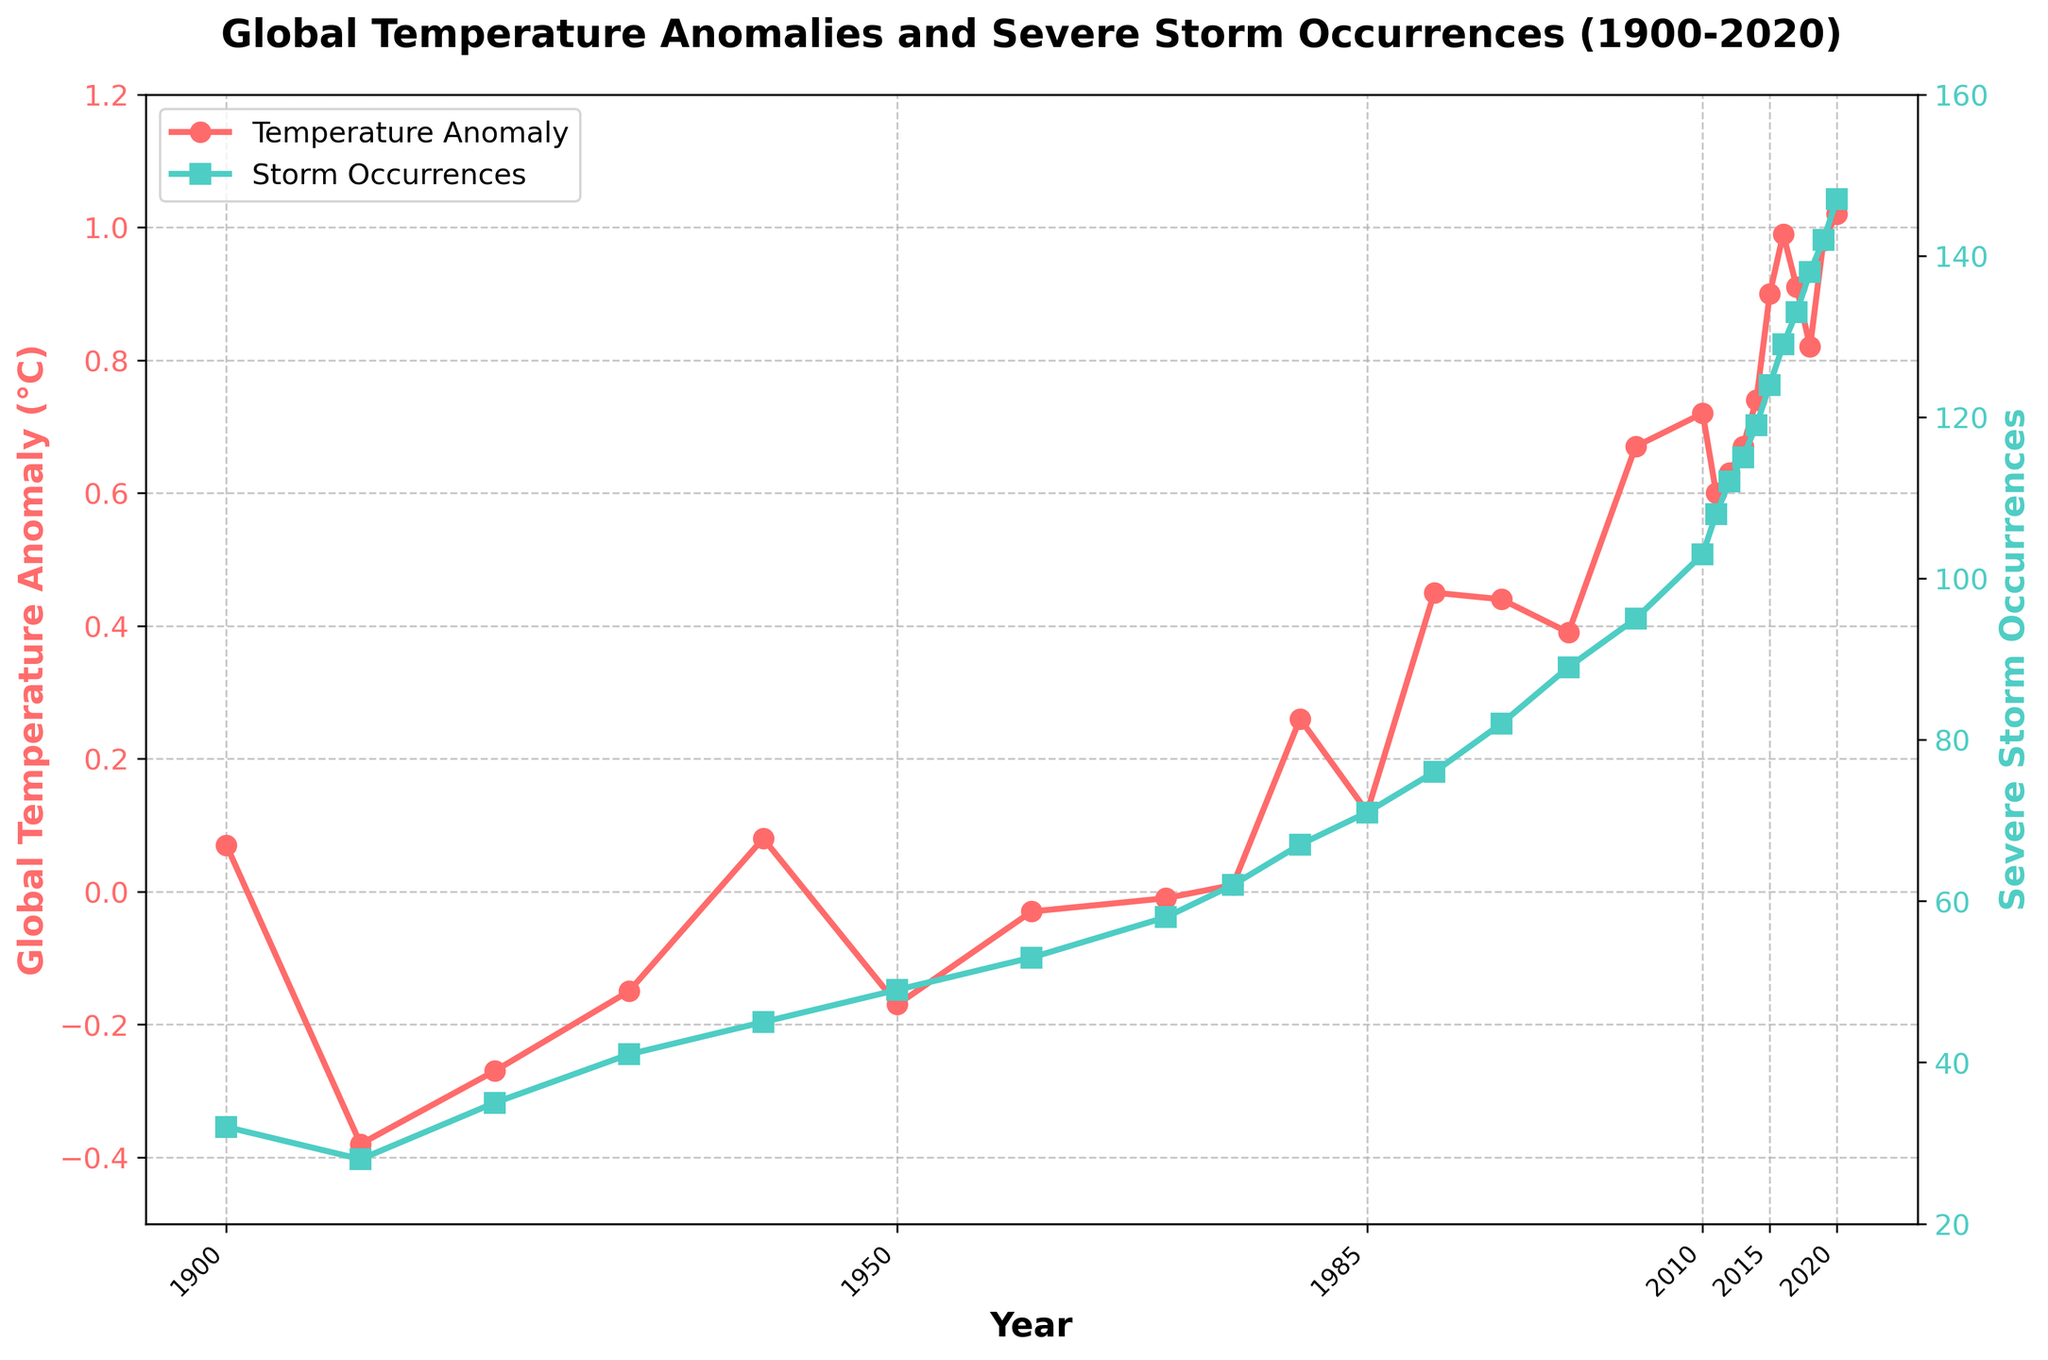What is the overall trend in global temperature anomalies from 1900 to 2020? The red line representing global temperature anomalies shows a general increase from 1900 to 2020, indicated by points moving upward. The anomaly values start at around 0.07°C in 1900 and rise to approximately 1.02°C in 2020, indicating a trend of increasing temperatures.
Answer: Increasing trend How does the number of severe storm occurrences in 2020 compare to 1900? In 1900, there were 32 severe storm occurrences, while in 2020, there were 147. By comparing the two data points on the green line, we see an increase in storm occurrences over this time span.
Answer: Increased What is the correlation between global temperature anomalies and severe storm occurrences? Both the red and green lines generally trend upwards over the years. As the temperature anomaly increases, the number of severe storm occurrences also increases, indicating a positive correlation between global temperature anomalies and severe storm occurrences.
Answer: Positive correlation In which year did the global temperature anomaly first exceed 0.5°C? By examining the red line, the first time the anomaly exceeds 0.5°C is around the year 1990.
Answer: 1990 How many more severe storm occurrences were there in 2010 compared to 1950? In 1950, there were 49 storm occurrences, and in 2010, there were 103. Subtracting the 1950 value from the 2010 value gives: 103 - 49 = 54 additional occurrences.
Answer: 54 Which year experienced the highest global temperature anomaly? The red line peaks in 2020 at an anomaly value of approximately 1.02°C, which is the highest point on the plot.
Answer: 2020 Identify the year with the highest number of severe storm occurrences and state the count. The green line peaks at the end of the timeline in 2020, with 147 severe storm occurrences, the highest observed value.
Answer: 2020, 147 During which decade did global temperature anomalies make a noticeable rise above 0°C for the first time? Examining the red line, we see that temperature anomalies consistently rise above 0°C starting in the 1940s.
Answer: 1940s By how much did the global temperature anomaly change from 1980 to 1990? In 1980, the temperature anomaly was 0.26°C, and in 1990, it was 0.45°C. The change is found by subtracting the 1980 value from the 1990 value: 0.45 - 0.26 = 0.19°C.
Answer: 0.19°C Compare the severe storm occurrences in 1970 and 1985. Which year had fewer storms and what was the difference in their counts? In 1970, there were 58 severe storm occurrences, and in 1985, there were 71. Hence, 1970 had fewer storms. The difference is: 71 - 58 = 13 storms.
Answer: 1970, 13 